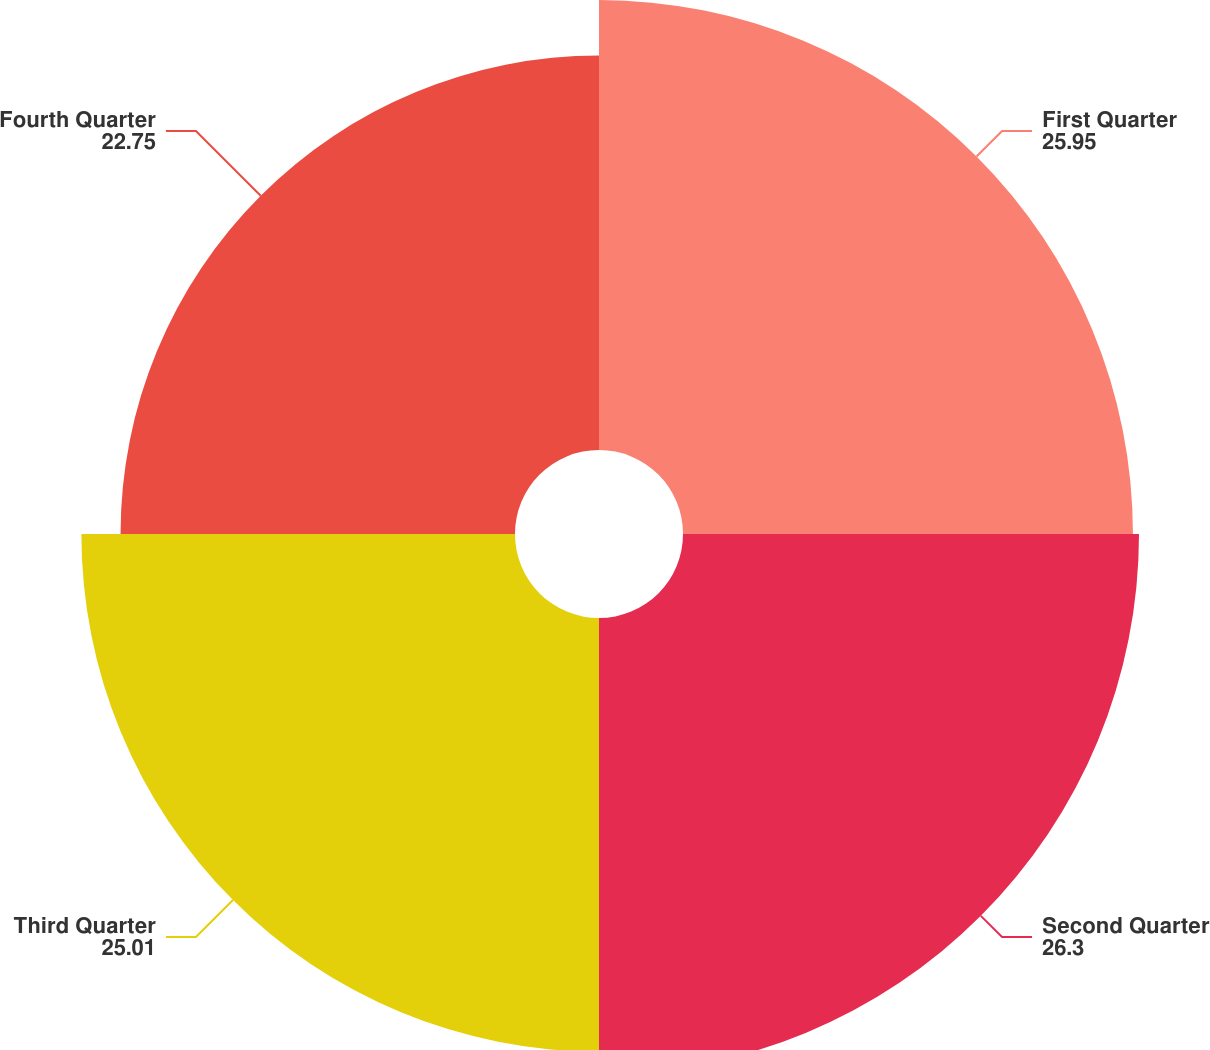<chart> <loc_0><loc_0><loc_500><loc_500><pie_chart><fcel>First Quarter<fcel>Second Quarter<fcel>Third Quarter<fcel>Fourth Quarter<nl><fcel>25.95%<fcel>26.3%<fcel>25.01%<fcel>22.75%<nl></chart> 